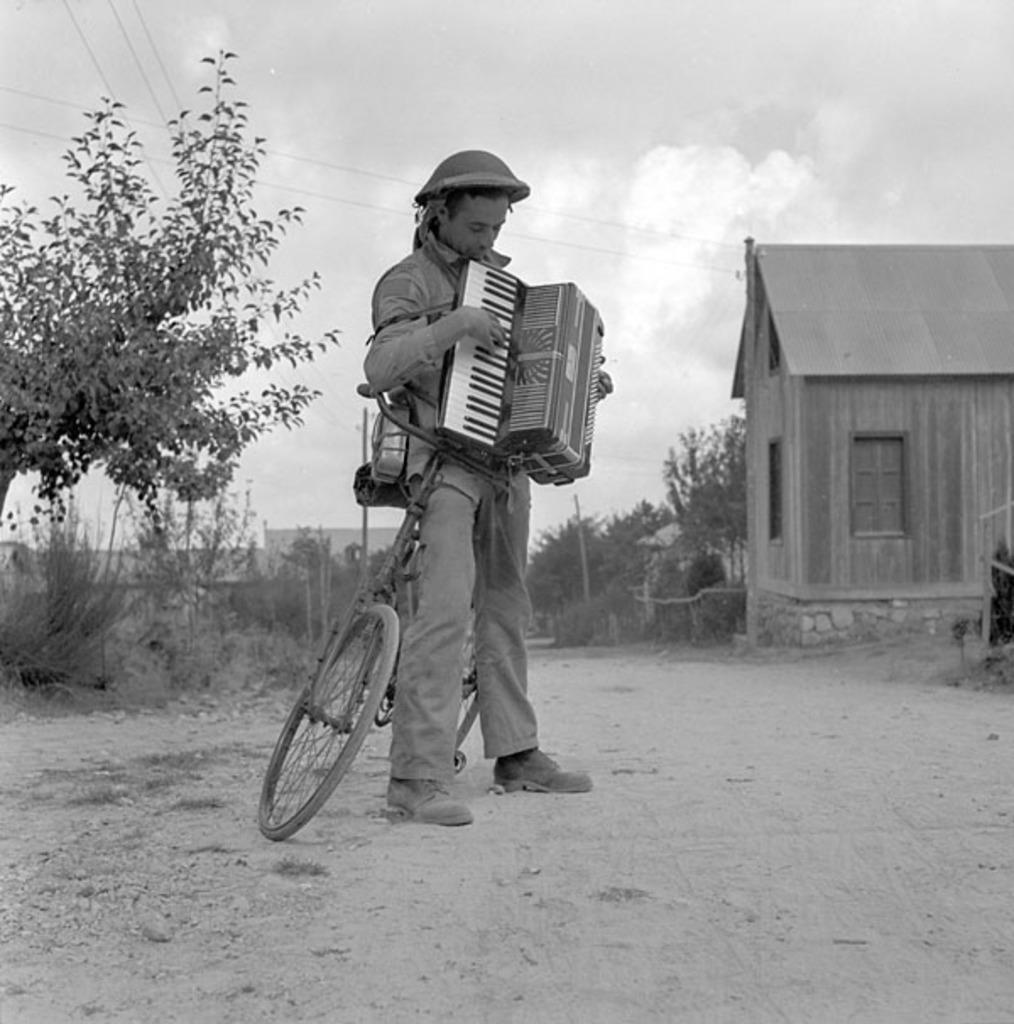How would you summarize this image in a sentence or two? In the image I can see a person who is holding the music instrument and standing next to the cycle and also I can see a house and some trees plants and poles. 